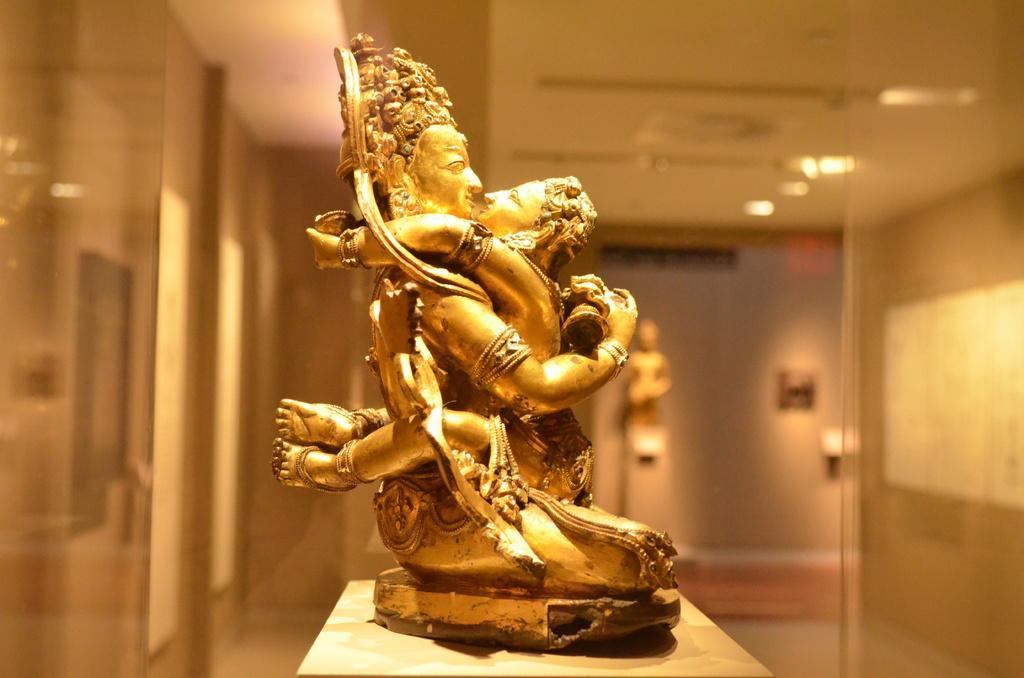How would you summarize this image in a sentence or two? In this picture we can see a statue on a platform and in the background we can see lights, walls, roof, statue and it is blurry. 